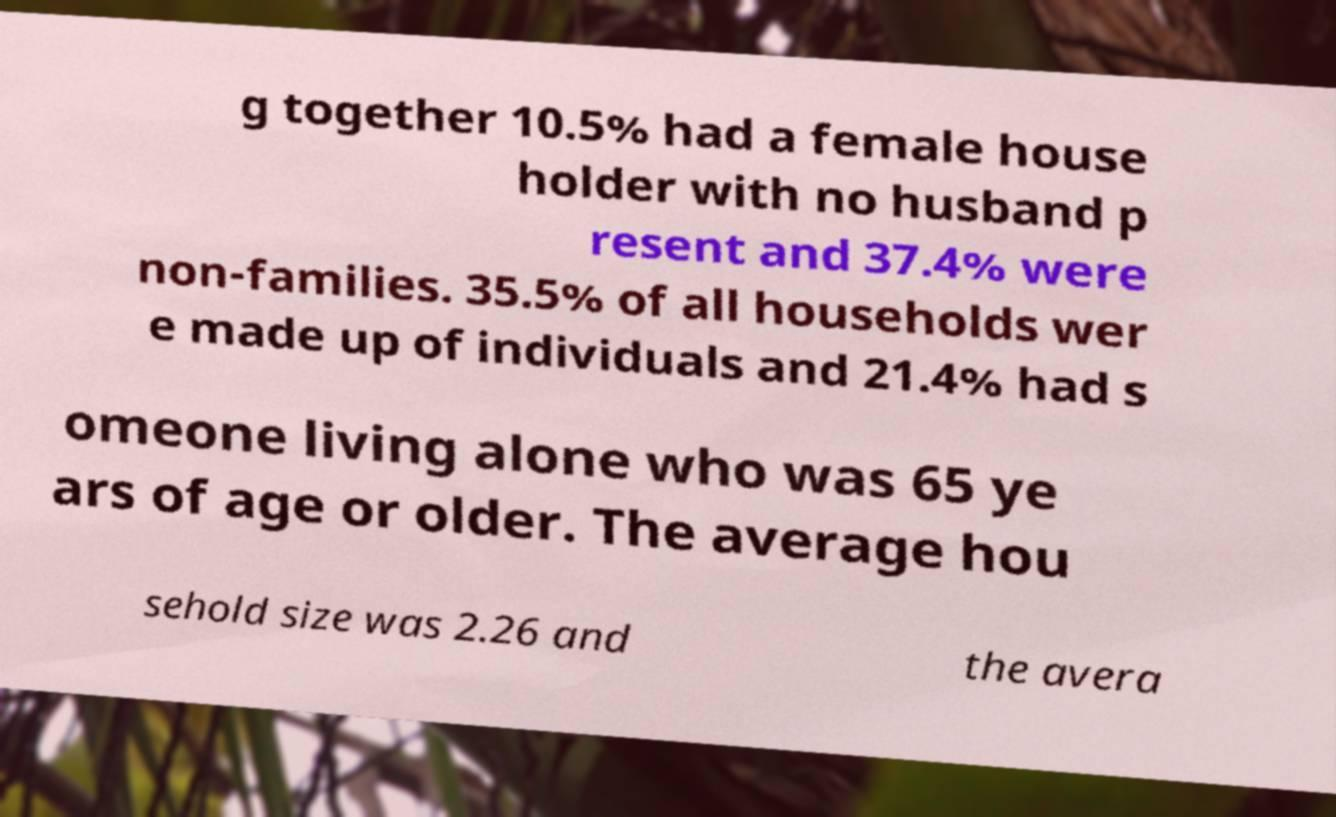Please identify and transcribe the text found in this image. g together 10.5% had a female house holder with no husband p resent and 37.4% were non-families. 35.5% of all households wer e made up of individuals and 21.4% had s omeone living alone who was 65 ye ars of age or older. The average hou sehold size was 2.26 and the avera 